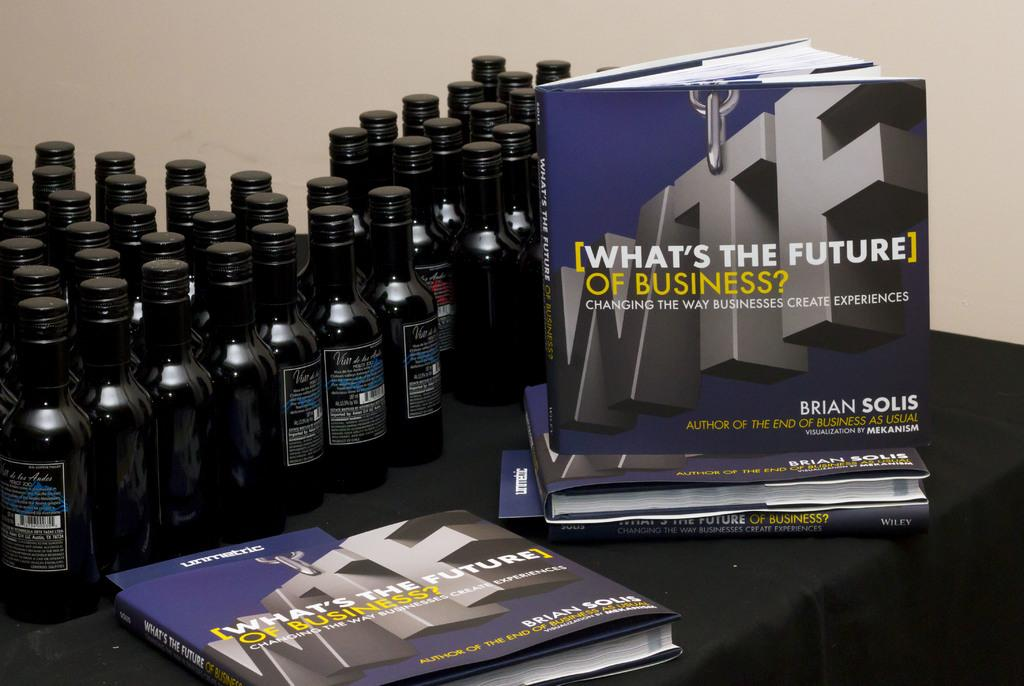<image>
Relay a brief, clear account of the picture shown. A lot of bottles are sitting on a table behind copies of the book What's the Future of Business. 